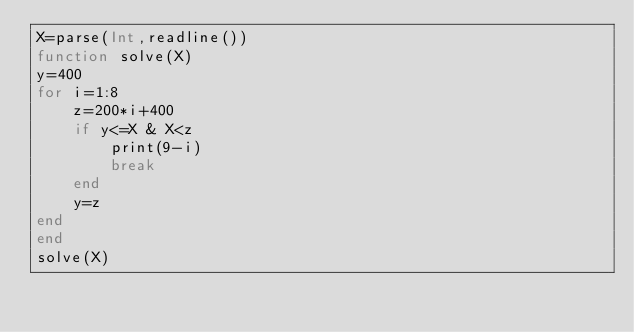Convert code to text. <code><loc_0><loc_0><loc_500><loc_500><_Julia_>X=parse(Int,readline())
function solve(X)
y=400
for i=1:8
    z=200*i+400
    if y<=X & X<z
        print(9-i)
        break
    end
    y=z
end
end
solve(X)</code> 